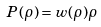Convert formula to latex. <formula><loc_0><loc_0><loc_500><loc_500>P ( \rho ) = w ( \rho ) \rho</formula> 